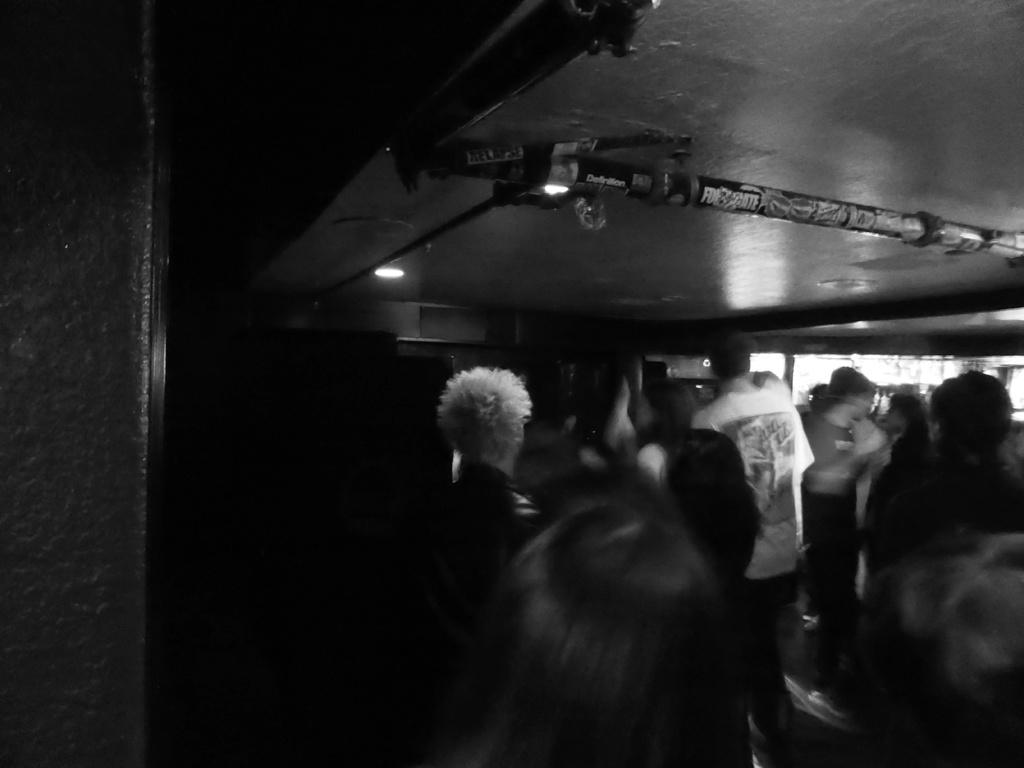What can be seen in the image in terms of people? There are groups of people in the image. How would you describe the lighting in the image? The image is a little dark. What type of structure can be seen in the image? There is a wall visible in the image. What type of mint is being used to clean the roof in the image? There is no roof or mint present in the image. 